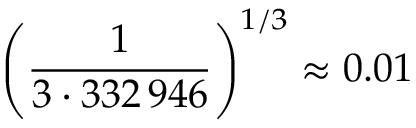<formula> <loc_0><loc_0><loc_500><loc_500>\left ( { \frac { 1 } { 3 \cdot 3 3 2 \, 9 4 6 } } \right ) ^ { 1 / 3 } \approx 0 . 0 1</formula> 